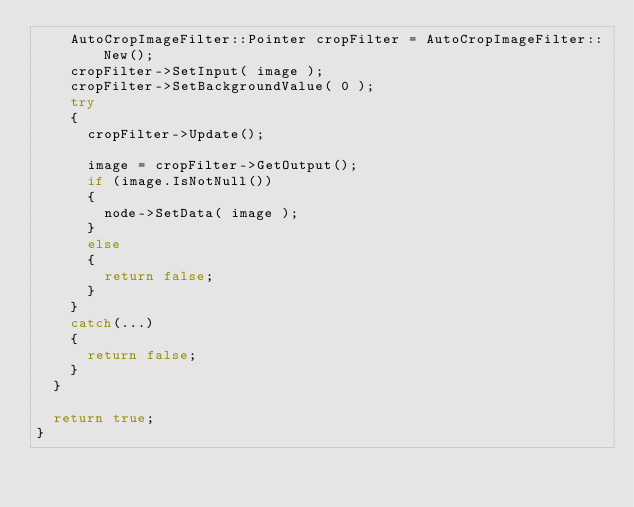Convert code to text. <code><loc_0><loc_0><loc_500><loc_500><_C++_>    AutoCropImageFilter::Pointer cropFilter = AutoCropImageFilter::New();
    cropFilter->SetInput( image );
    cropFilter->SetBackgroundValue( 0 );
    try
    {
      cropFilter->Update();

      image = cropFilter->GetOutput();
      if (image.IsNotNull())
      {
        node->SetData( image );
      }
      else
      {
        return false;
      }
    }
    catch(...)
    {
      return false;
    }
  }

  return true;
}

</code> 